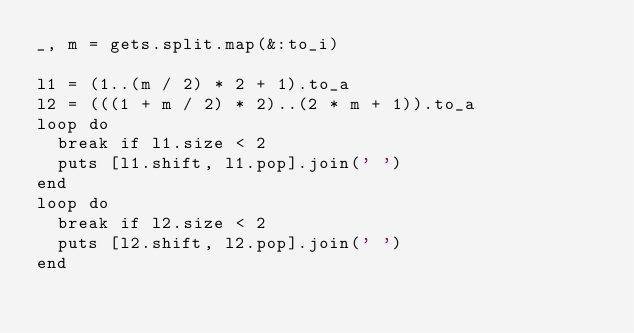<code> <loc_0><loc_0><loc_500><loc_500><_Ruby_>_, m = gets.split.map(&:to_i)

l1 = (1..(m / 2) * 2 + 1).to_a
l2 = (((1 + m / 2) * 2)..(2 * m + 1)).to_a
loop do
  break if l1.size < 2
  puts [l1.shift, l1.pop].join(' ')
end
loop do
  break if l2.size < 2
  puts [l2.shift, l2.pop].join(' ')
end</code> 